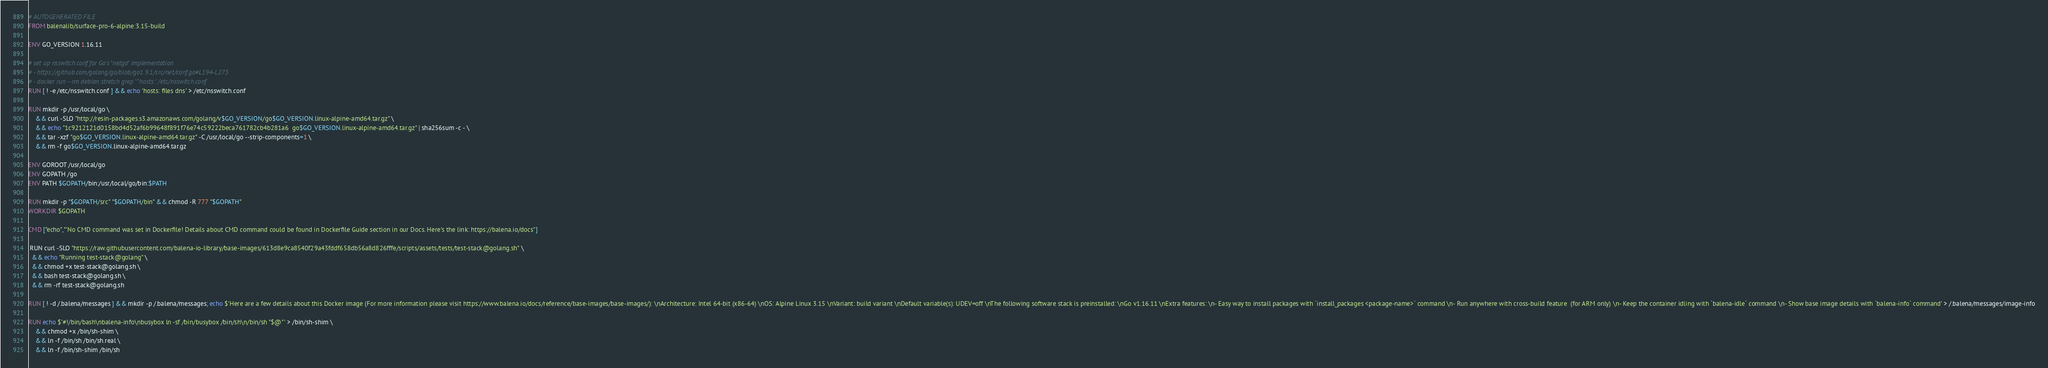<code> <loc_0><loc_0><loc_500><loc_500><_Dockerfile_># AUTOGENERATED FILE
FROM balenalib/surface-pro-6-alpine:3.15-build

ENV GO_VERSION 1.16.11

# set up nsswitch.conf for Go's "netgo" implementation
# - https://github.com/golang/go/blob/go1.9.1/src/net/conf.go#L194-L275
# - docker run --rm debian:stretch grep '^hosts:' /etc/nsswitch.conf
RUN [ ! -e /etc/nsswitch.conf ] && echo 'hosts: files dns' > /etc/nsswitch.conf

RUN mkdir -p /usr/local/go \
	&& curl -SLO "http://resin-packages.s3.amazonaws.com/golang/v$GO_VERSION/go$GO_VERSION.linux-alpine-amd64.tar.gz" \
	&& echo "1c9212121d0158bd4d52af6b99648f891f76e74c59222beca761782cb4b281a6  go$GO_VERSION.linux-alpine-amd64.tar.gz" | sha256sum -c - \
	&& tar -xzf "go$GO_VERSION.linux-alpine-amd64.tar.gz" -C /usr/local/go --strip-components=1 \
	&& rm -f go$GO_VERSION.linux-alpine-amd64.tar.gz

ENV GOROOT /usr/local/go
ENV GOPATH /go
ENV PATH $GOPATH/bin:/usr/local/go/bin:$PATH

RUN mkdir -p "$GOPATH/src" "$GOPATH/bin" && chmod -R 777 "$GOPATH"
WORKDIR $GOPATH

CMD ["echo","'No CMD command was set in Dockerfile! Details about CMD command could be found in Dockerfile Guide section in our Docs. Here's the link: https://balena.io/docs"]

 RUN curl -SLO "https://raw.githubusercontent.com/balena-io-library/base-images/613d8e9ca8540f29a43fddf658db56a8d826fffe/scripts/assets/tests/test-stack@golang.sh" \
  && echo "Running test-stack@golang" \
  && chmod +x test-stack@golang.sh \
  && bash test-stack@golang.sh \
  && rm -rf test-stack@golang.sh 

RUN [ ! -d /.balena/messages ] && mkdir -p /.balena/messages; echo $'Here are a few details about this Docker image (For more information please visit https://www.balena.io/docs/reference/base-images/base-images/): \nArchitecture: Intel 64-bit (x86-64) \nOS: Alpine Linux 3.15 \nVariant: build variant \nDefault variable(s): UDEV=off \nThe following software stack is preinstalled: \nGo v1.16.11 \nExtra features: \n- Easy way to install packages with `install_packages <package-name>` command \n- Run anywhere with cross-build feature  (for ARM only) \n- Keep the container idling with `balena-idle` command \n- Show base image details with `balena-info` command' > /.balena/messages/image-info

RUN echo $'#!/bin/bash\nbalena-info\nbusybox ln -sf /bin/busybox /bin/sh\n/bin/sh "$@"' > /bin/sh-shim \
	&& chmod +x /bin/sh-shim \
	&& ln -f /bin/sh /bin/sh.real \
	&& ln -f /bin/sh-shim /bin/sh</code> 